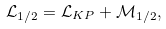<formula> <loc_0><loc_0><loc_500><loc_500>\mathcal { L } _ { 1 / 2 } = \mathcal { L } _ { K P } + \mathcal { M } _ { 1 / 2 } ,</formula> 